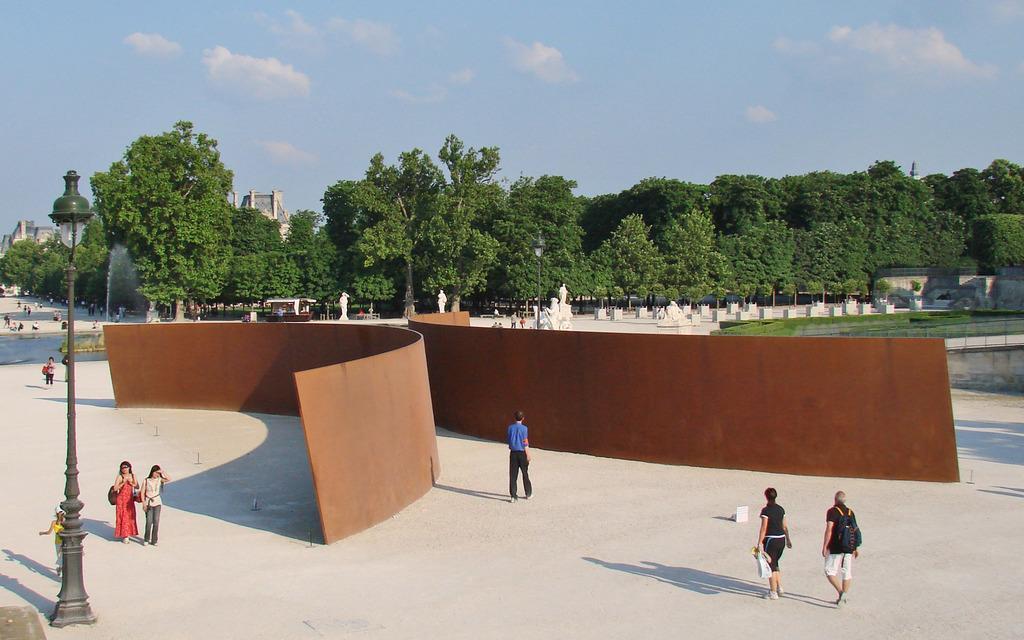How would you summarize this image in a sentence or two? On the left side, there are two women walking on a road. Beside them, there is a light attached to a pole. On the right side, there are three persons walking on the road and there are two brown color objects. In the background, there are trees, poles, persons, water and there are clouds in the sky. 